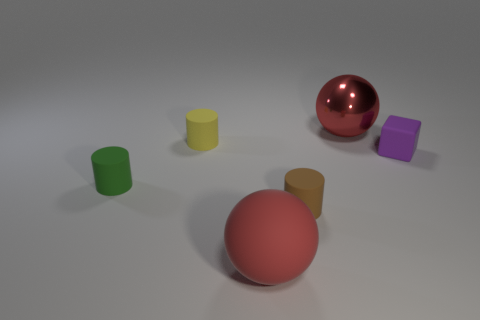There is a yellow thing that is the same shape as the brown object; what is its material? The yellow object, resembling the shape of the brown one, appears to be made of a plastic material, common for objects like children's toys or lightweight household items. 